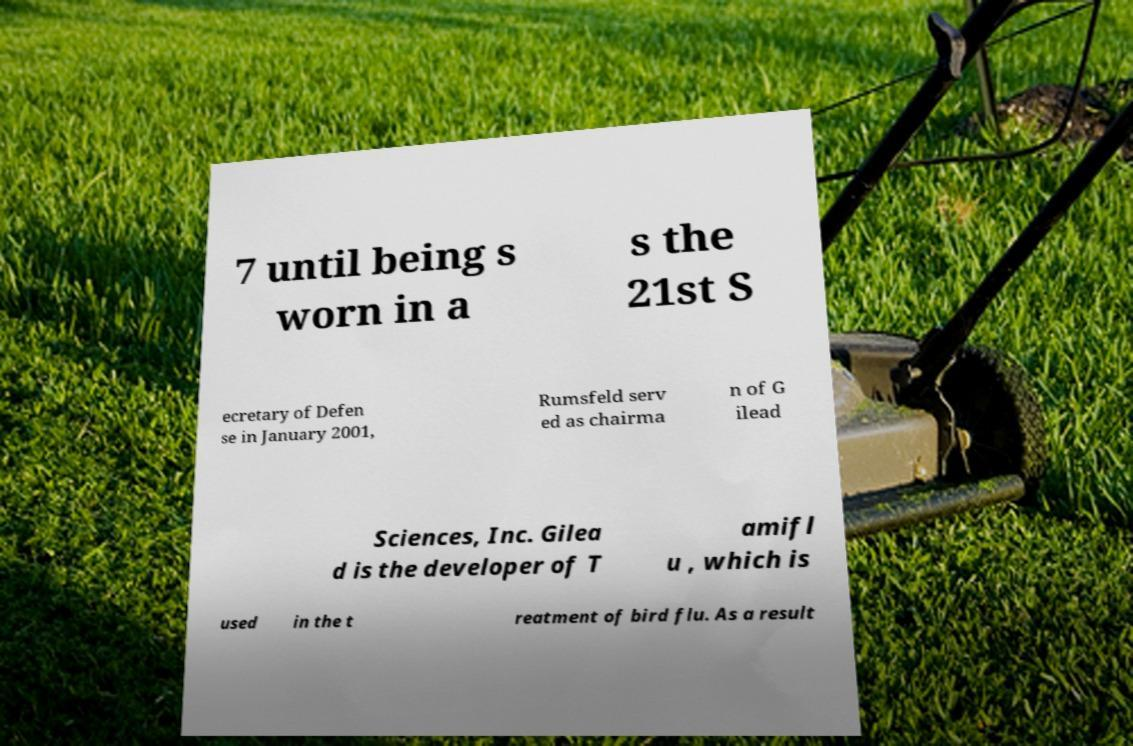Could you assist in decoding the text presented in this image and type it out clearly? 7 until being s worn in a s the 21st S ecretary of Defen se in January 2001, Rumsfeld serv ed as chairma n of G ilead Sciences, Inc. Gilea d is the developer of T amifl u , which is used in the t reatment of bird flu. As a result 